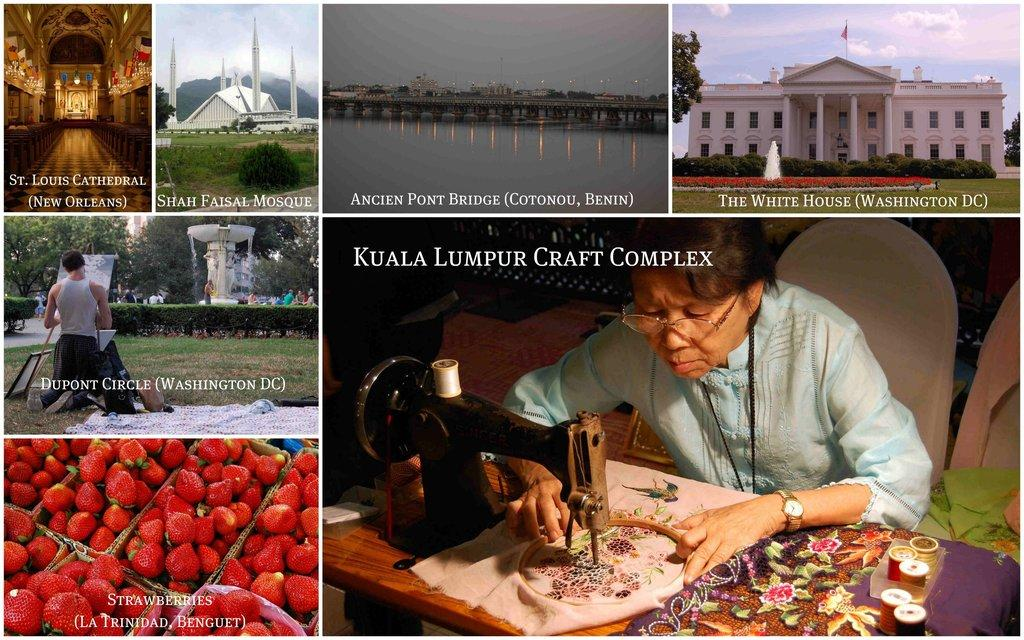What type of structure can be seen in the image? There is a building in the image. What part of the natural environment is visible in the image? The sky, water, grass, and trees are visible in the image. What is the person sitting on the right side of the image doing? The person is sitting on a chair on the right side of the image. What items can be seen in the image that are not related to the building or natural environment? There is a sewing machine and strawberries visible in the image. What song is the fireman singing while touching his toe in the image? There is no fireman or toe-touching in the image. The image does not depict any singing or musical activity. 